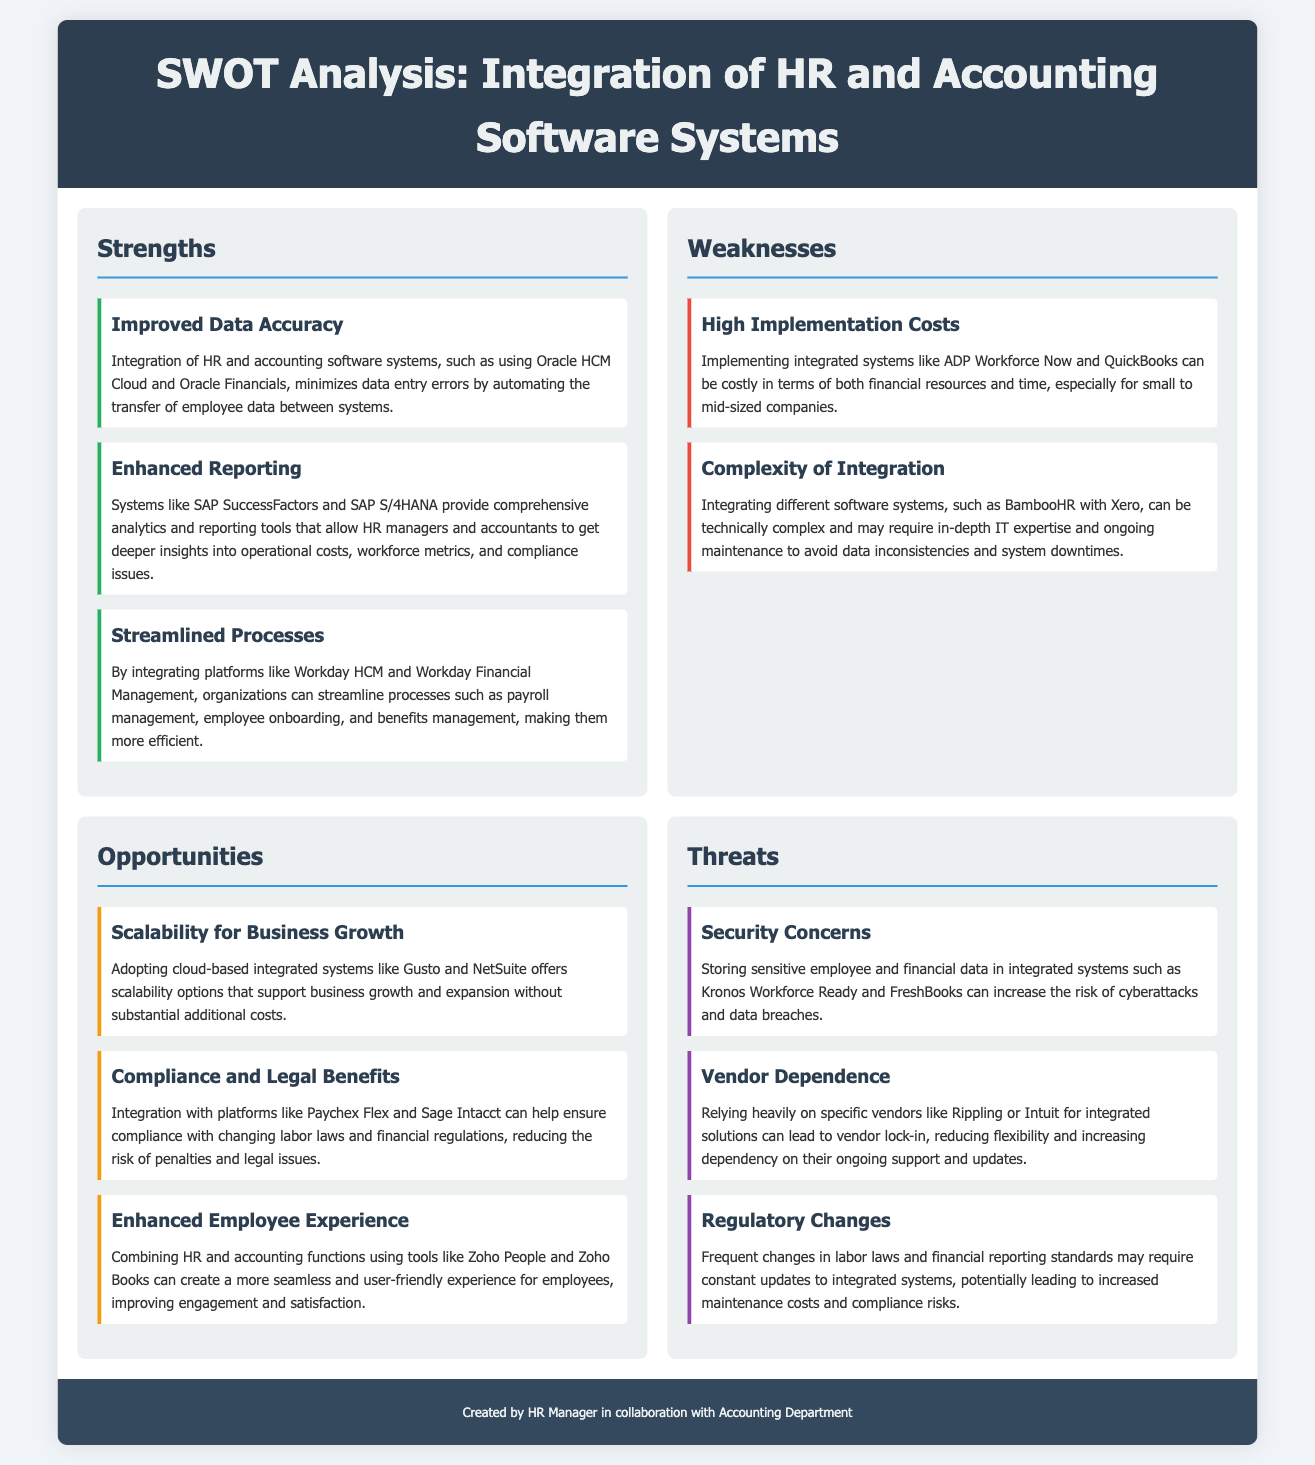What is one strength of integrating HR and accounting systems? The document outlines various strengths, one of which is "Improved Data Accuracy," which refers to minimizing data entry errors through automation.
Answer: Improved Data Accuracy What is a weakness associated with high implementation costs? The document states that high implementation costs can be particularly challenging for "small to mid-sized companies," making it a significant weakness.
Answer: small to mid-sized companies What opportunity does adopting integrated systems provide for business growth? The document mentions that adopting cloud-based integrated systems offers "scalability options" which support business growth.
Answer: scalability options What is a threat related to security? According to the document, one of the threats involves "Security Concerns," specifically regarding the risks associated with cyberattacks and data breaches.
Answer: Security Concerns Which software system is mentioned in the strength related to enhanced reporting? The document lists "SAP SuccessFactors" as part of the strength focusing on providing comprehensive analytics and reporting tools.
Answer: SAP SuccessFactors What is the main challenge mentioned under the weakness of complexity of integration? The document indicates that the main challenge involves the "technical complexity" associated with integrating different software systems.
Answer: technical complexity Which software is highlighted as assisting with compliance and legal benefits? The document specifically mentions "Paychex Flex" as a platform that helps ensure compliance with changing labor laws.
Answer: Paychex Flex How many weaknesses are identified in the SWOT analysis? The document identifies two weaknesses in the SWOT analysis regarding integration: high implementation costs and complexity of integration.
Answer: two What kind of experience does integrating HR and accounting functions aim to enhance for employees? The document mentions that integration aims to create a "more seamless and user-friendly experience" for employees, improving engagement and satisfaction.
Answer: more seamless and user-friendly experience 